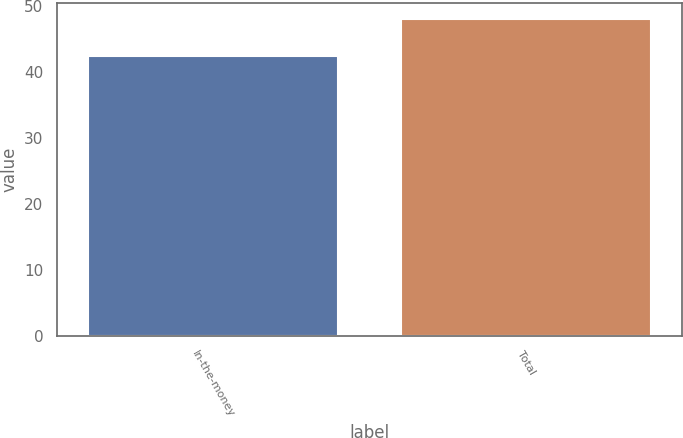<chart> <loc_0><loc_0><loc_500><loc_500><bar_chart><fcel>In-the-money<fcel>Total<nl><fcel>42.49<fcel>48.12<nl></chart> 